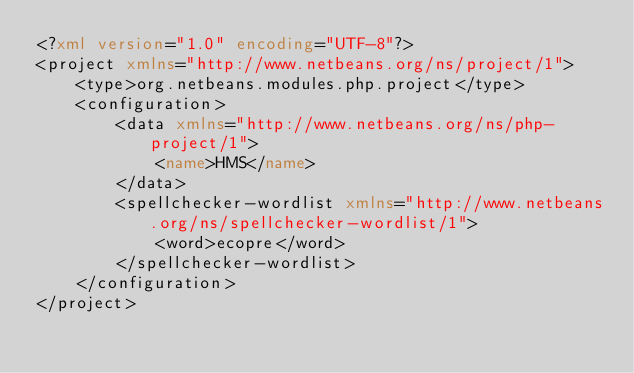Convert code to text. <code><loc_0><loc_0><loc_500><loc_500><_XML_><?xml version="1.0" encoding="UTF-8"?>
<project xmlns="http://www.netbeans.org/ns/project/1">
    <type>org.netbeans.modules.php.project</type>
    <configuration>
        <data xmlns="http://www.netbeans.org/ns/php-project/1">
            <name>HMS</name>
        </data>
        <spellchecker-wordlist xmlns="http://www.netbeans.org/ns/spellchecker-wordlist/1">
            <word>ecopre</word>
        </spellchecker-wordlist>
    </configuration>
</project>
</code> 